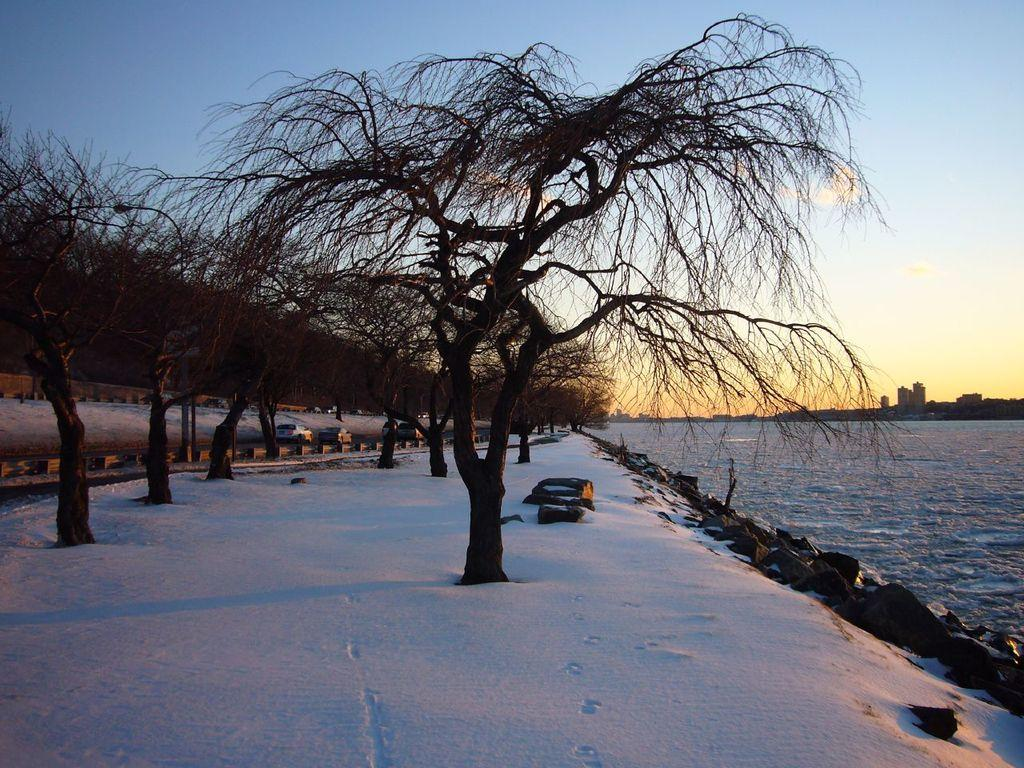What type of weather is depicted in the image? There is snow in the image, indicating cold weather. What natural elements can be seen in the image? There are trees in the image. What man-made objects are present in the image? There are vehicles in the image. What type of ground surface is visible in the image? There are stones in the image. What can be seen in the background of the image? The sky is visible in the background of the image. What type of hat is the church wearing in the image? There is no church or hat present in the image. What is the plot of the story being told in the image? The image does not depict a story or plot; it is a scene with snow, trees, vehicles, stones, and the sky. 